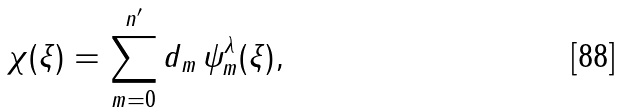<formula> <loc_0><loc_0><loc_500><loc_500>\chi ( \xi ) = \sum _ { m = 0 } ^ { n ^ { \prime } } d _ { m } \, \psi _ { m } ^ { \lambda } ( \xi ) ,</formula> 